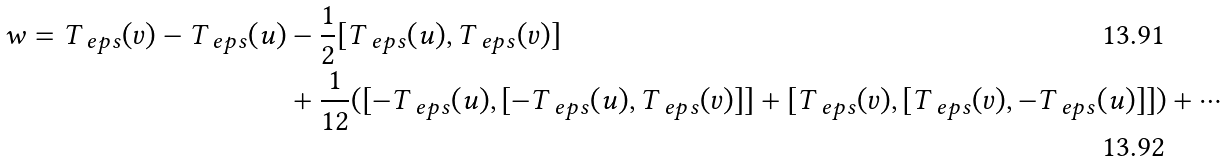<formula> <loc_0><loc_0><loc_500><loc_500>w = T _ { \ e p s } ( v ) - T _ { \ e p s } ( u ) & - \frac { 1 } { 2 } [ T _ { \ e p s } ( u ) , T _ { \ e p s } ( v ) ] \\ & + \frac { 1 } { 1 2 } ( [ - T _ { \ e p s } ( u ) , [ - T _ { \ e p s } ( u ) , T _ { \ e p s } ( v ) ] ] + [ T _ { \ e p s } ( v ) , [ T _ { \ e p s } ( v ) , - T _ { \ e p s } ( u ) ] ] ) + \cdots</formula> 